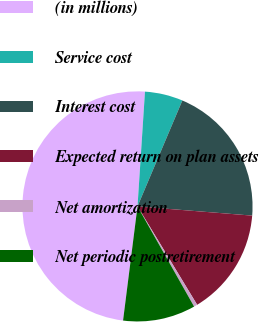Convert chart to OTSL. <chart><loc_0><loc_0><loc_500><loc_500><pie_chart><fcel>(in millions)<fcel>Service cost<fcel>Interest cost<fcel>Expected return on plan assets<fcel>Net amortization<fcel>Net periodic postretirement<nl><fcel>49.03%<fcel>5.34%<fcel>19.9%<fcel>15.05%<fcel>0.49%<fcel>10.19%<nl></chart> 